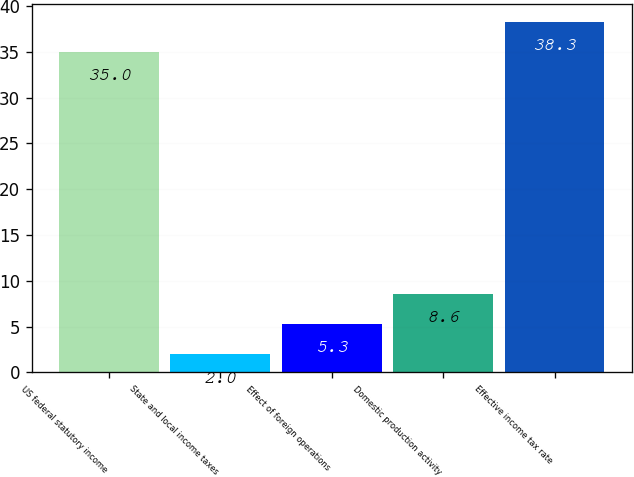<chart> <loc_0><loc_0><loc_500><loc_500><bar_chart><fcel>US federal statutory income<fcel>State and local income taxes<fcel>Effect of foreign operations<fcel>Domestic production activity<fcel>Effective income tax rate<nl><fcel>35<fcel>2<fcel>5.3<fcel>8.6<fcel>38.3<nl></chart> 